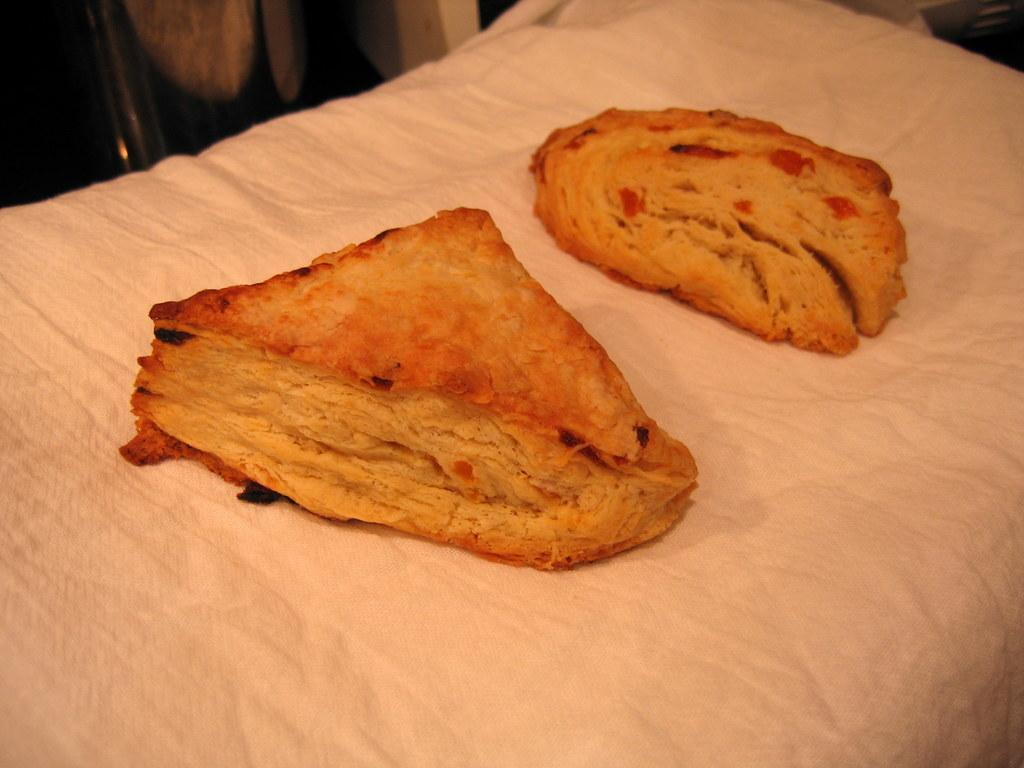What is the main subject of the image? The main subject of the image is two bread pieces. Where are the bread pieces located in the image? The bread pieces are in the middle of the image. Is there any other object or material visible with the bread pieces? The bread pieces might be placed on a cloth. What type of doll is sitting next to the bread pieces in the image? There is no doll present in the image; it only features two bread pieces and possibly a cloth. 